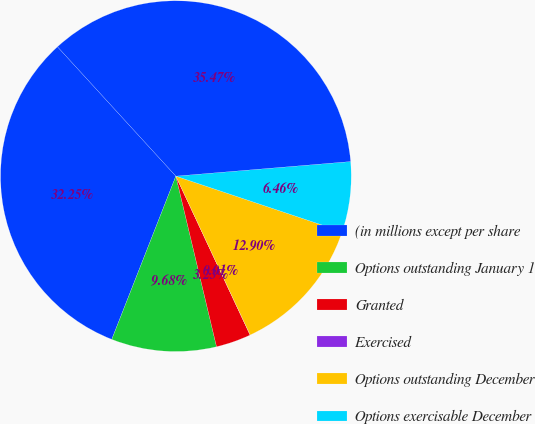<chart> <loc_0><loc_0><loc_500><loc_500><pie_chart><fcel>(in millions except per share<fcel>Options outstanding January 1<fcel>Granted<fcel>Exercised<fcel>Options outstanding December<fcel>Options exercisable December<fcel>Weighted Average Exercise<nl><fcel>32.25%<fcel>9.68%<fcel>3.23%<fcel>0.01%<fcel>12.9%<fcel>6.46%<fcel>35.47%<nl></chart> 